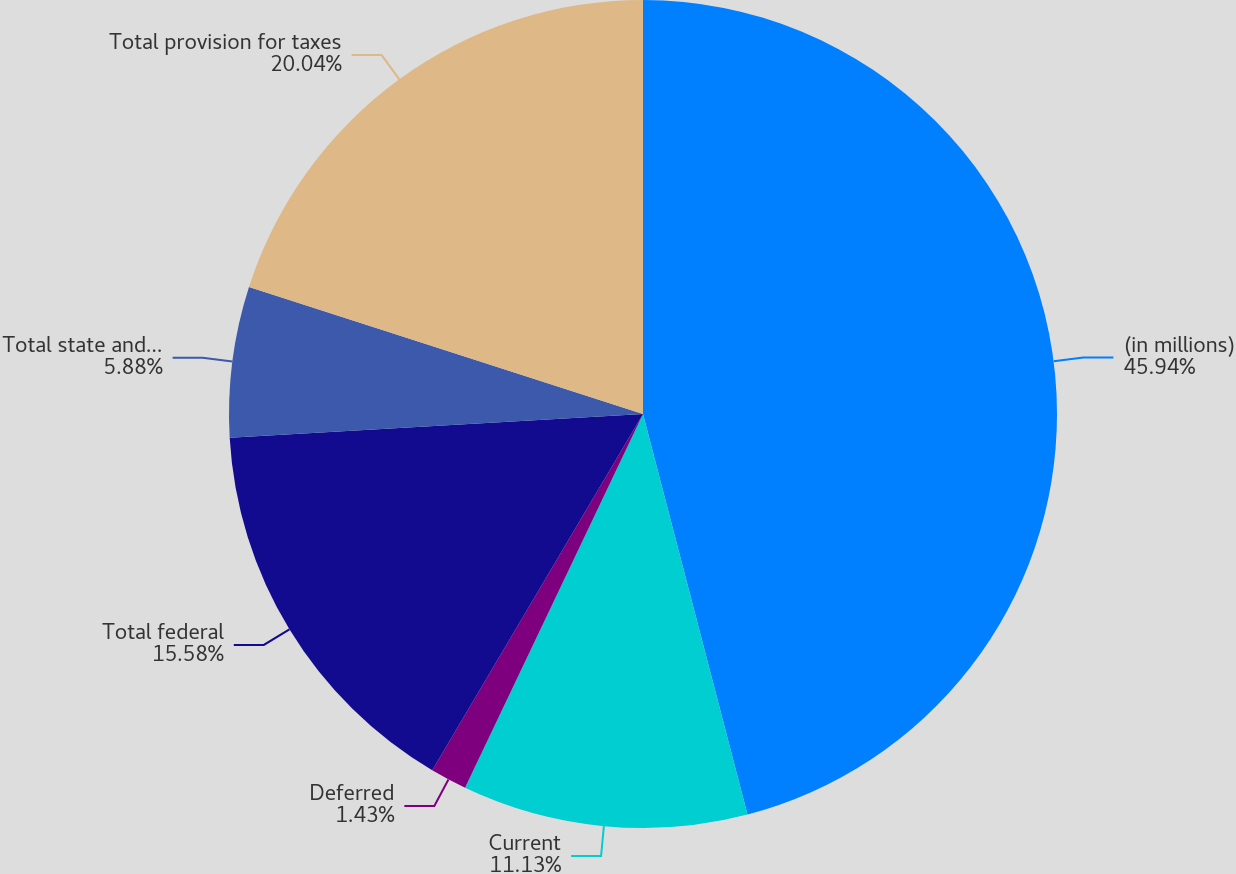<chart> <loc_0><loc_0><loc_500><loc_500><pie_chart><fcel>(in millions)<fcel>Current<fcel>Deferred<fcel>Total federal<fcel>Total state and local<fcel>Total provision for taxes<nl><fcel>45.93%<fcel>11.13%<fcel>1.43%<fcel>15.58%<fcel>5.88%<fcel>20.03%<nl></chart> 